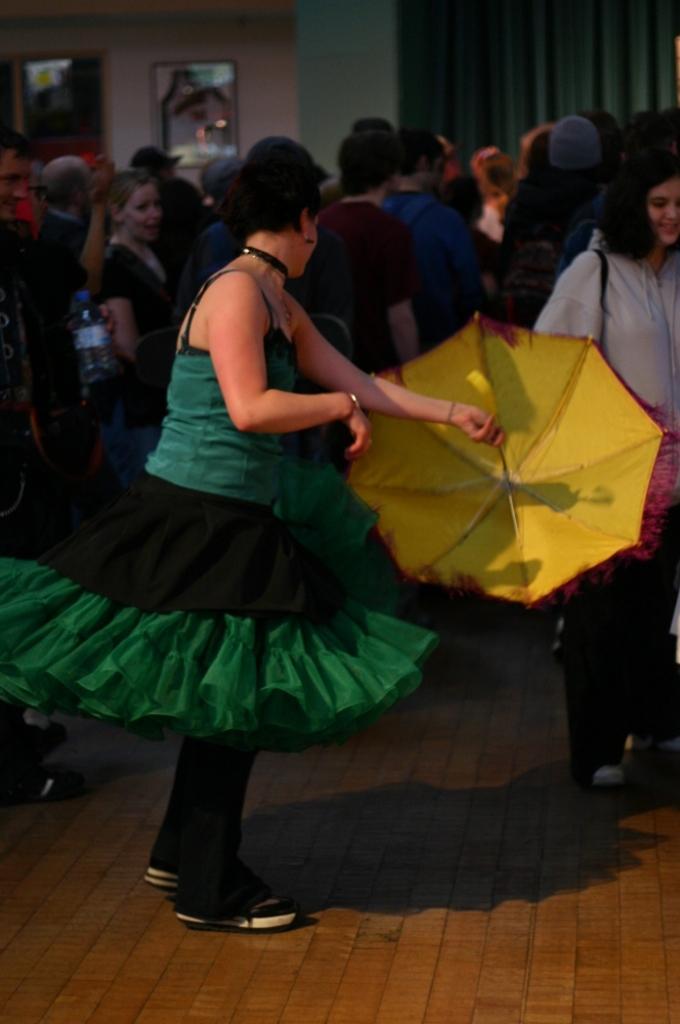Could you give a brief overview of what you see in this image? The picture may be taken in a party. In the center of the picture there is a woman holding an umbrella. In the background there are people dancing. At the top there are curtain, frame, door and wall. 